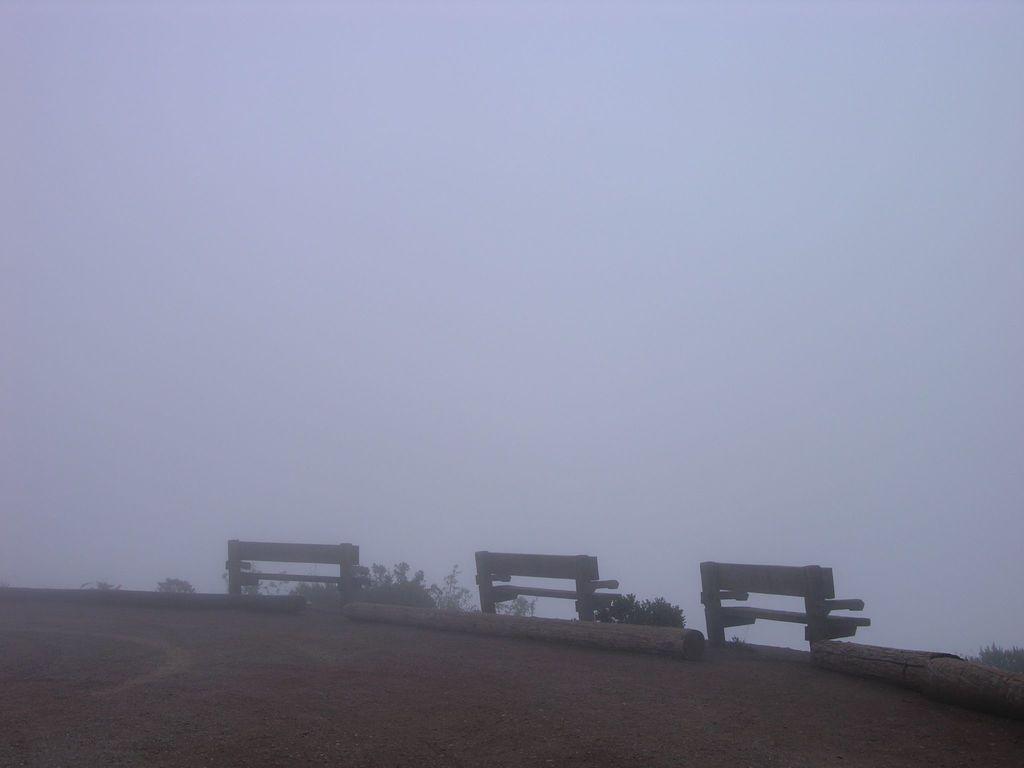Could you give a brief overview of what you see in this image? In this picture I can observe three benches on the land. I can observe fog in this picture. 